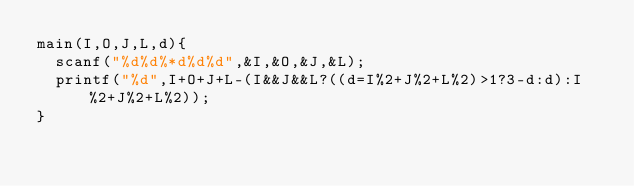Convert code to text. <code><loc_0><loc_0><loc_500><loc_500><_C_>main(I,O,J,L,d){
	scanf("%d%d%*d%d%d",&I,&O,&J,&L);
	printf("%d",I+O+J+L-(I&&J&&L?((d=I%2+J%2+L%2)>1?3-d:d):I%2+J%2+L%2));
}</code> 